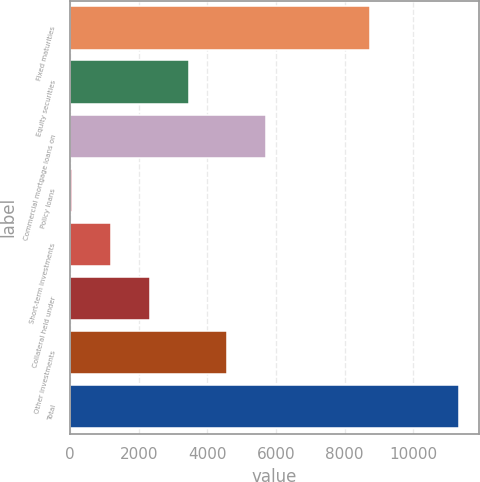Convert chart. <chart><loc_0><loc_0><loc_500><loc_500><bar_chart><fcel>Fixed maturities<fcel>Equity securities<fcel>Commercial mortgage loans on<fcel>Policy loans<fcel>Short-term investments<fcel>Collateral held under<fcel>Other investments<fcel>Total<nl><fcel>8729<fcel>3450.8<fcel>5706<fcel>68<fcel>1195.6<fcel>2323.2<fcel>4578.4<fcel>11344<nl></chart> 